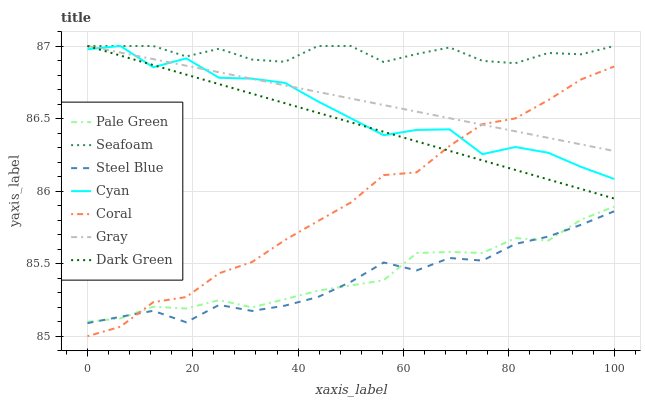Does Steel Blue have the minimum area under the curve?
Answer yes or no. Yes. Does Seafoam have the maximum area under the curve?
Answer yes or no. Yes. Does Coral have the minimum area under the curve?
Answer yes or no. No. Does Coral have the maximum area under the curve?
Answer yes or no. No. Is Dark Green the smoothest?
Answer yes or no. Yes. Is Cyan the roughest?
Answer yes or no. Yes. Is Coral the smoothest?
Answer yes or no. No. Is Coral the roughest?
Answer yes or no. No. Does Coral have the lowest value?
Answer yes or no. Yes. Does Seafoam have the lowest value?
Answer yes or no. No. Does Dark Green have the highest value?
Answer yes or no. Yes. Does Coral have the highest value?
Answer yes or no. No. Is Steel Blue less than Gray?
Answer yes or no. Yes. Is Seafoam greater than Steel Blue?
Answer yes or no. Yes. Does Steel Blue intersect Pale Green?
Answer yes or no. Yes. Is Steel Blue less than Pale Green?
Answer yes or no. No. Is Steel Blue greater than Pale Green?
Answer yes or no. No. Does Steel Blue intersect Gray?
Answer yes or no. No. 